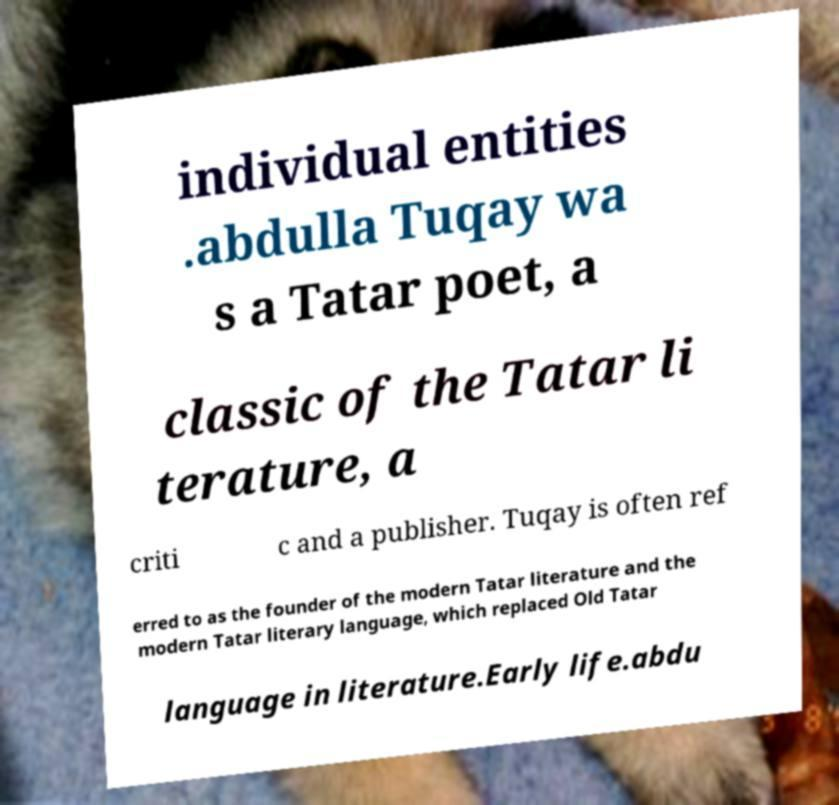What messages or text are displayed in this image? I need them in a readable, typed format. individual entities .abdulla Tuqay wa s a Tatar poet, a classic of the Tatar li terature, a criti c and a publisher. Tuqay is often ref erred to as the founder of the modern Tatar literature and the modern Tatar literary language, which replaced Old Tatar language in literature.Early life.abdu 